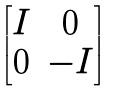<formula> <loc_0><loc_0><loc_500><loc_500>\begin{bmatrix} I & 0 \\ 0 & - I \\ \end{bmatrix}</formula> 